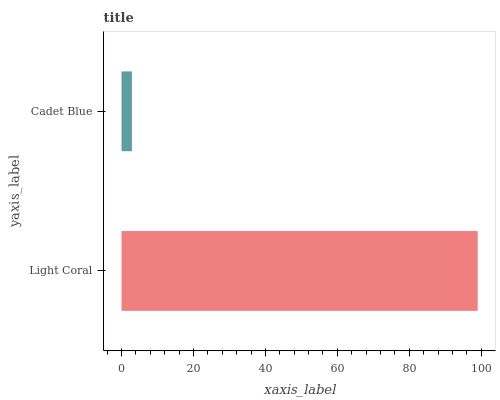Is Cadet Blue the minimum?
Answer yes or no. Yes. Is Light Coral the maximum?
Answer yes or no. Yes. Is Cadet Blue the maximum?
Answer yes or no. No. Is Light Coral greater than Cadet Blue?
Answer yes or no. Yes. Is Cadet Blue less than Light Coral?
Answer yes or no. Yes. Is Cadet Blue greater than Light Coral?
Answer yes or no. No. Is Light Coral less than Cadet Blue?
Answer yes or no. No. Is Light Coral the high median?
Answer yes or no. Yes. Is Cadet Blue the low median?
Answer yes or no. Yes. Is Cadet Blue the high median?
Answer yes or no. No. Is Light Coral the low median?
Answer yes or no. No. 